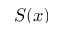<formula> <loc_0><loc_0><loc_500><loc_500>S ( x )</formula> 